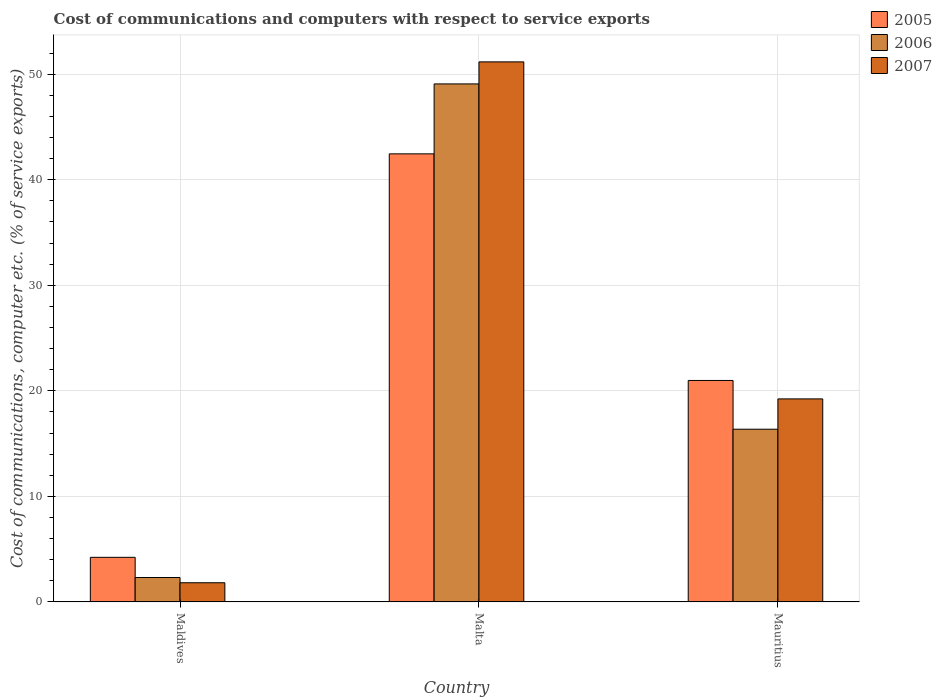How many different coloured bars are there?
Offer a terse response. 3. How many groups of bars are there?
Make the answer very short. 3. Are the number of bars per tick equal to the number of legend labels?
Provide a short and direct response. Yes. How many bars are there on the 2nd tick from the left?
Give a very brief answer. 3. What is the label of the 2nd group of bars from the left?
Provide a short and direct response. Malta. In how many cases, is the number of bars for a given country not equal to the number of legend labels?
Make the answer very short. 0. What is the cost of communications and computers in 2006 in Mauritius?
Provide a short and direct response. 16.37. Across all countries, what is the maximum cost of communications and computers in 2005?
Your response must be concise. 42.46. Across all countries, what is the minimum cost of communications and computers in 2006?
Keep it short and to the point. 2.32. In which country was the cost of communications and computers in 2005 maximum?
Give a very brief answer. Malta. In which country was the cost of communications and computers in 2007 minimum?
Your answer should be compact. Maldives. What is the total cost of communications and computers in 2007 in the graph?
Provide a succinct answer. 72.23. What is the difference between the cost of communications and computers in 2005 in Maldives and that in Malta?
Your response must be concise. -38.23. What is the difference between the cost of communications and computers in 2006 in Malta and the cost of communications and computers in 2007 in Mauritius?
Provide a succinct answer. 29.84. What is the average cost of communications and computers in 2005 per country?
Give a very brief answer. 22.56. What is the difference between the cost of communications and computers of/in 2007 and cost of communications and computers of/in 2005 in Maldives?
Give a very brief answer. -2.41. In how many countries, is the cost of communications and computers in 2005 greater than 16 %?
Give a very brief answer. 2. What is the ratio of the cost of communications and computers in 2006 in Maldives to that in Mauritius?
Give a very brief answer. 0.14. Is the cost of communications and computers in 2007 in Maldives less than that in Mauritius?
Ensure brevity in your answer.  Yes. What is the difference between the highest and the second highest cost of communications and computers in 2007?
Ensure brevity in your answer.  17.42. What is the difference between the highest and the lowest cost of communications and computers in 2007?
Provide a succinct answer. 49.35. In how many countries, is the cost of communications and computers in 2006 greater than the average cost of communications and computers in 2006 taken over all countries?
Your answer should be very brief. 1. Is the sum of the cost of communications and computers in 2006 in Malta and Mauritius greater than the maximum cost of communications and computers in 2005 across all countries?
Provide a short and direct response. Yes. Is it the case that in every country, the sum of the cost of communications and computers in 2007 and cost of communications and computers in 2006 is greater than the cost of communications and computers in 2005?
Keep it short and to the point. No. How many bars are there?
Keep it short and to the point. 9. How many countries are there in the graph?
Provide a succinct answer. 3. Are the values on the major ticks of Y-axis written in scientific E-notation?
Give a very brief answer. No. Does the graph contain any zero values?
Make the answer very short. No. Does the graph contain grids?
Keep it short and to the point. Yes. How many legend labels are there?
Provide a short and direct response. 3. How are the legend labels stacked?
Give a very brief answer. Vertical. What is the title of the graph?
Offer a very short reply. Cost of communications and computers with respect to service exports. Does "1973" appear as one of the legend labels in the graph?
Make the answer very short. No. What is the label or title of the X-axis?
Provide a succinct answer. Country. What is the label or title of the Y-axis?
Give a very brief answer. Cost of communications, computer etc. (% of service exports). What is the Cost of communications, computer etc. (% of service exports) in 2005 in Maldives?
Offer a very short reply. 4.23. What is the Cost of communications, computer etc. (% of service exports) of 2006 in Maldives?
Give a very brief answer. 2.32. What is the Cost of communications, computer etc. (% of service exports) of 2007 in Maldives?
Provide a succinct answer. 1.82. What is the Cost of communications, computer etc. (% of service exports) of 2005 in Malta?
Ensure brevity in your answer.  42.46. What is the Cost of communications, computer etc. (% of service exports) in 2006 in Malta?
Your answer should be very brief. 49.08. What is the Cost of communications, computer etc. (% of service exports) of 2007 in Malta?
Give a very brief answer. 51.17. What is the Cost of communications, computer etc. (% of service exports) in 2005 in Mauritius?
Give a very brief answer. 20.99. What is the Cost of communications, computer etc. (% of service exports) in 2006 in Mauritius?
Offer a terse response. 16.37. What is the Cost of communications, computer etc. (% of service exports) in 2007 in Mauritius?
Give a very brief answer. 19.24. Across all countries, what is the maximum Cost of communications, computer etc. (% of service exports) of 2005?
Offer a very short reply. 42.46. Across all countries, what is the maximum Cost of communications, computer etc. (% of service exports) of 2006?
Offer a very short reply. 49.08. Across all countries, what is the maximum Cost of communications, computer etc. (% of service exports) of 2007?
Offer a very short reply. 51.17. Across all countries, what is the minimum Cost of communications, computer etc. (% of service exports) of 2005?
Offer a terse response. 4.23. Across all countries, what is the minimum Cost of communications, computer etc. (% of service exports) in 2006?
Keep it short and to the point. 2.32. Across all countries, what is the minimum Cost of communications, computer etc. (% of service exports) of 2007?
Your answer should be compact. 1.82. What is the total Cost of communications, computer etc. (% of service exports) in 2005 in the graph?
Provide a succinct answer. 67.67. What is the total Cost of communications, computer etc. (% of service exports) of 2006 in the graph?
Offer a very short reply. 67.76. What is the total Cost of communications, computer etc. (% of service exports) in 2007 in the graph?
Ensure brevity in your answer.  72.23. What is the difference between the Cost of communications, computer etc. (% of service exports) in 2005 in Maldives and that in Malta?
Keep it short and to the point. -38.23. What is the difference between the Cost of communications, computer etc. (% of service exports) of 2006 in Maldives and that in Malta?
Offer a very short reply. -46.77. What is the difference between the Cost of communications, computer etc. (% of service exports) of 2007 in Maldives and that in Malta?
Keep it short and to the point. -49.35. What is the difference between the Cost of communications, computer etc. (% of service exports) in 2005 in Maldives and that in Mauritius?
Provide a succinct answer. -16.76. What is the difference between the Cost of communications, computer etc. (% of service exports) in 2006 in Maldives and that in Mauritius?
Provide a succinct answer. -14.05. What is the difference between the Cost of communications, computer etc. (% of service exports) in 2007 in Maldives and that in Mauritius?
Your answer should be compact. -17.42. What is the difference between the Cost of communications, computer etc. (% of service exports) in 2005 in Malta and that in Mauritius?
Keep it short and to the point. 21.47. What is the difference between the Cost of communications, computer etc. (% of service exports) of 2006 in Malta and that in Mauritius?
Provide a short and direct response. 32.72. What is the difference between the Cost of communications, computer etc. (% of service exports) of 2007 in Malta and that in Mauritius?
Provide a succinct answer. 31.93. What is the difference between the Cost of communications, computer etc. (% of service exports) of 2005 in Maldives and the Cost of communications, computer etc. (% of service exports) of 2006 in Malta?
Ensure brevity in your answer.  -44.85. What is the difference between the Cost of communications, computer etc. (% of service exports) of 2005 in Maldives and the Cost of communications, computer etc. (% of service exports) of 2007 in Malta?
Offer a very short reply. -46.94. What is the difference between the Cost of communications, computer etc. (% of service exports) in 2006 in Maldives and the Cost of communications, computer etc. (% of service exports) in 2007 in Malta?
Ensure brevity in your answer.  -48.85. What is the difference between the Cost of communications, computer etc. (% of service exports) in 2005 in Maldives and the Cost of communications, computer etc. (% of service exports) in 2006 in Mauritius?
Offer a very short reply. -12.14. What is the difference between the Cost of communications, computer etc. (% of service exports) in 2005 in Maldives and the Cost of communications, computer etc. (% of service exports) in 2007 in Mauritius?
Your answer should be very brief. -15.01. What is the difference between the Cost of communications, computer etc. (% of service exports) of 2006 in Maldives and the Cost of communications, computer etc. (% of service exports) of 2007 in Mauritius?
Your answer should be compact. -16.92. What is the difference between the Cost of communications, computer etc. (% of service exports) of 2005 in Malta and the Cost of communications, computer etc. (% of service exports) of 2006 in Mauritius?
Offer a very short reply. 26.09. What is the difference between the Cost of communications, computer etc. (% of service exports) of 2005 in Malta and the Cost of communications, computer etc. (% of service exports) of 2007 in Mauritius?
Provide a succinct answer. 23.22. What is the difference between the Cost of communications, computer etc. (% of service exports) of 2006 in Malta and the Cost of communications, computer etc. (% of service exports) of 2007 in Mauritius?
Give a very brief answer. 29.84. What is the average Cost of communications, computer etc. (% of service exports) of 2005 per country?
Offer a very short reply. 22.56. What is the average Cost of communications, computer etc. (% of service exports) in 2006 per country?
Keep it short and to the point. 22.59. What is the average Cost of communications, computer etc. (% of service exports) in 2007 per country?
Provide a succinct answer. 24.08. What is the difference between the Cost of communications, computer etc. (% of service exports) of 2005 and Cost of communications, computer etc. (% of service exports) of 2006 in Maldives?
Keep it short and to the point. 1.91. What is the difference between the Cost of communications, computer etc. (% of service exports) in 2005 and Cost of communications, computer etc. (% of service exports) in 2007 in Maldives?
Provide a short and direct response. 2.41. What is the difference between the Cost of communications, computer etc. (% of service exports) of 2006 and Cost of communications, computer etc. (% of service exports) of 2007 in Maldives?
Ensure brevity in your answer.  0.5. What is the difference between the Cost of communications, computer etc. (% of service exports) of 2005 and Cost of communications, computer etc. (% of service exports) of 2006 in Malta?
Offer a terse response. -6.63. What is the difference between the Cost of communications, computer etc. (% of service exports) of 2005 and Cost of communications, computer etc. (% of service exports) of 2007 in Malta?
Give a very brief answer. -8.71. What is the difference between the Cost of communications, computer etc. (% of service exports) of 2006 and Cost of communications, computer etc. (% of service exports) of 2007 in Malta?
Ensure brevity in your answer.  -2.09. What is the difference between the Cost of communications, computer etc. (% of service exports) in 2005 and Cost of communications, computer etc. (% of service exports) in 2006 in Mauritius?
Ensure brevity in your answer.  4.62. What is the difference between the Cost of communications, computer etc. (% of service exports) of 2005 and Cost of communications, computer etc. (% of service exports) of 2007 in Mauritius?
Your response must be concise. 1.75. What is the difference between the Cost of communications, computer etc. (% of service exports) of 2006 and Cost of communications, computer etc. (% of service exports) of 2007 in Mauritius?
Offer a very short reply. -2.87. What is the ratio of the Cost of communications, computer etc. (% of service exports) in 2005 in Maldives to that in Malta?
Your answer should be very brief. 0.1. What is the ratio of the Cost of communications, computer etc. (% of service exports) of 2006 in Maldives to that in Malta?
Keep it short and to the point. 0.05. What is the ratio of the Cost of communications, computer etc. (% of service exports) of 2007 in Maldives to that in Malta?
Give a very brief answer. 0.04. What is the ratio of the Cost of communications, computer etc. (% of service exports) of 2005 in Maldives to that in Mauritius?
Offer a very short reply. 0.2. What is the ratio of the Cost of communications, computer etc. (% of service exports) of 2006 in Maldives to that in Mauritius?
Ensure brevity in your answer.  0.14. What is the ratio of the Cost of communications, computer etc. (% of service exports) in 2007 in Maldives to that in Mauritius?
Offer a terse response. 0.09. What is the ratio of the Cost of communications, computer etc. (% of service exports) of 2005 in Malta to that in Mauritius?
Offer a very short reply. 2.02. What is the ratio of the Cost of communications, computer etc. (% of service exports) of 2006 in Malta to that in Mauritius?
Your response must be concise. 3. What is the ratio of the Cost of communications, computer etc. (% of service exports) of 2007 in Malta to that in Mauritius?
Give a very brief answer. 2.66. What is the difference between the highest and the second highest Cost of communications, computer etc. (% of service exports) of 2005?
Your answer should be very brief. 21.47. What is the difference between the highest and the second highest Cost of communications, computer etc. (% of service exports) of 2006?
Your answer should be compact. 32.72. What is the difference between the highest and the second highest Cost of communications, computer etc. (% of service exports) of 2007?
Your response must be concise. 31.93. What is the difference between the highest and the lowest Cost of communications, computer etc. (% of service exports) in 2005?
Provide a short and direct response. 38.23. What is the difference between the highest and the lowest Cost of communications, computer etc. (% of service exports) of 2006?
Your answer should be very brief. 46.77. What is the difference between the highest and the lowest Cost of communications, computer etc. (% of service exports) of 2007?
Provide a short and direct response. 49.35. 